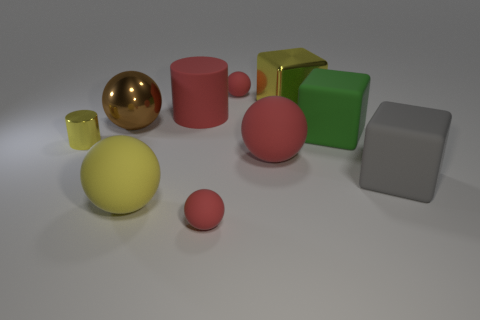How are the objects arranged in relation to each other? The objects are arranged in an asymmetrical but balanced composition. There appears to be no discernible pattern in their placement, which gives the scene a casual and natural feel. The varied sizes and colors of the objects create visual interest and help guide the viewer's eye throughout the image. 